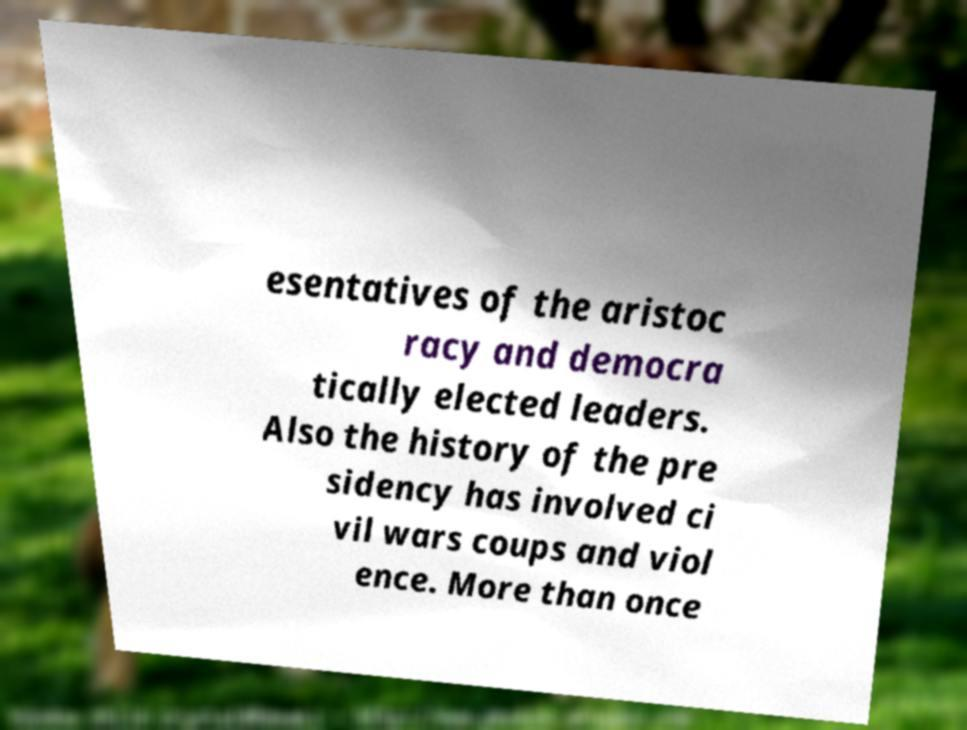Please read and relay the text visible in this image. What does it say? esentatives of the aristoc racy and democra tically elected leaders. Also the history of the pre sidency has involved ci vil wars coups and viol ence. More than once 